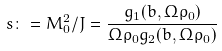Convert formula to latex. <formula><loc_0><loc_0><loc_500><loc_500>s \colon = M _ { 0 } ^ { 2 } / J = \frac { g _ { 1 } ( b , \Omega \rho _ { 0 } ) } { \Omega \rho _ { 0 } g _ { 2 } ( b , \Omega \rho _ { 0 } ) }</formula> 